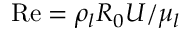<formula> <loc_0><loc_0><loc_500><loc_500>{ R e } = { \rho _ { l } } { R _ { 0 } } U / { \mu _ { l } }</formula> 